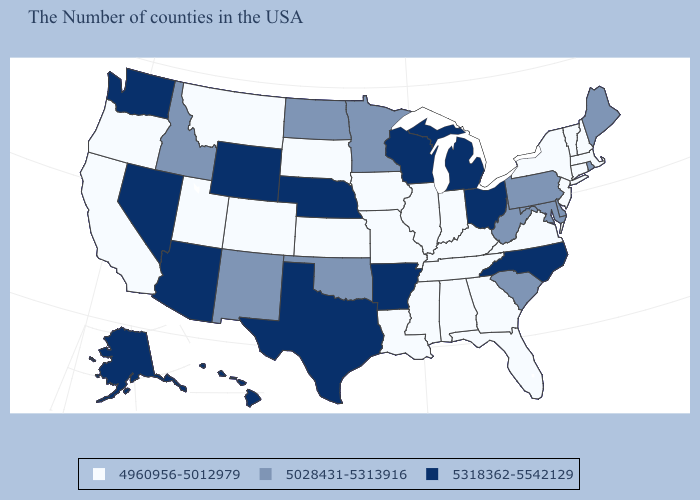What is the value of Delaware?
Concise answer only. 5028431-5313916. Which states have the lowest value in the Northeast?
Concise answer only. Massachusetts, New Hampshire, Vermont, Connecticut, New York, New Jersey. What is the value of New York?
Answer briefly. 4960956-5012979. What is the lowest value in states that border Mississippi?
Answer briefly. 4960956-5012979. What is the highest value in the USA?
Be succinct. 5318362-5542129. Does Ohio have the lowest value in the MidWest?
Quick response, please. No. Among the states that border Missouri , does Iowa have the lowest value?
Short answer required. Yes. Which states have the lowest value in the USA?
Give a very brief answer. Massachusetts, New Hampshire, Vermont, Connecticut, New York, New Jersey, Virginia, Florida, Georgia, Kentucky, Indiana, Alabama, Tennessee, Illinois, Mississippi, Louisiana, Missouri, Iowa, Kansas, South Dakota, Colorado, Utah, Montana, California, Oregon. What is the value of Arizona?
Concise answer only. 5318362-5542129. What is the lowest value in states that border Delaware?
Give a very brief answer. 4960956-5012979. What is the value of Alabama?
Write a very short answer. 4960956-5012979. Is the legend a continuous bar?
Give a very brief answer. No. Name the states that have a value in the range 5028431-5313916?
Be succinct. Maine, Rhode Island, Delaware, Maryland, Pennsylvania, South Carolina, West Virginia, Minnesota, Oklahoma, North Dakota, New Mexico, Idaho. What is the lowest value in the MidWest?
Write a very short answer. 4960956-5012979. Which states have the lowest value in the Northeast?
Write a very short answer. Massachusetts, New Hampshire, Vermont, Connecticut, New York, New Jersey. 